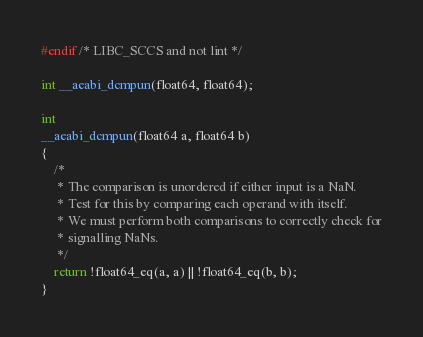<code> <loc_0><loc_0><loc_500><loc_500><_C_>#endif /* LIBC_SCCS and not lint */

int __aeabi_dcmpun(float64, float64);

int
__aeabi_dcmpun(float64 a, float64 b)
{
    /*
     * The comparison is unordered if either input is a NaN.
     * Test for this by comparing each operand with itself.
     * We must perform both comparisons to correctly check for
     * signalling NaNs.
     */
    return !float64_eq(a, a) || !float64_eq(b, b);
}
</code> 